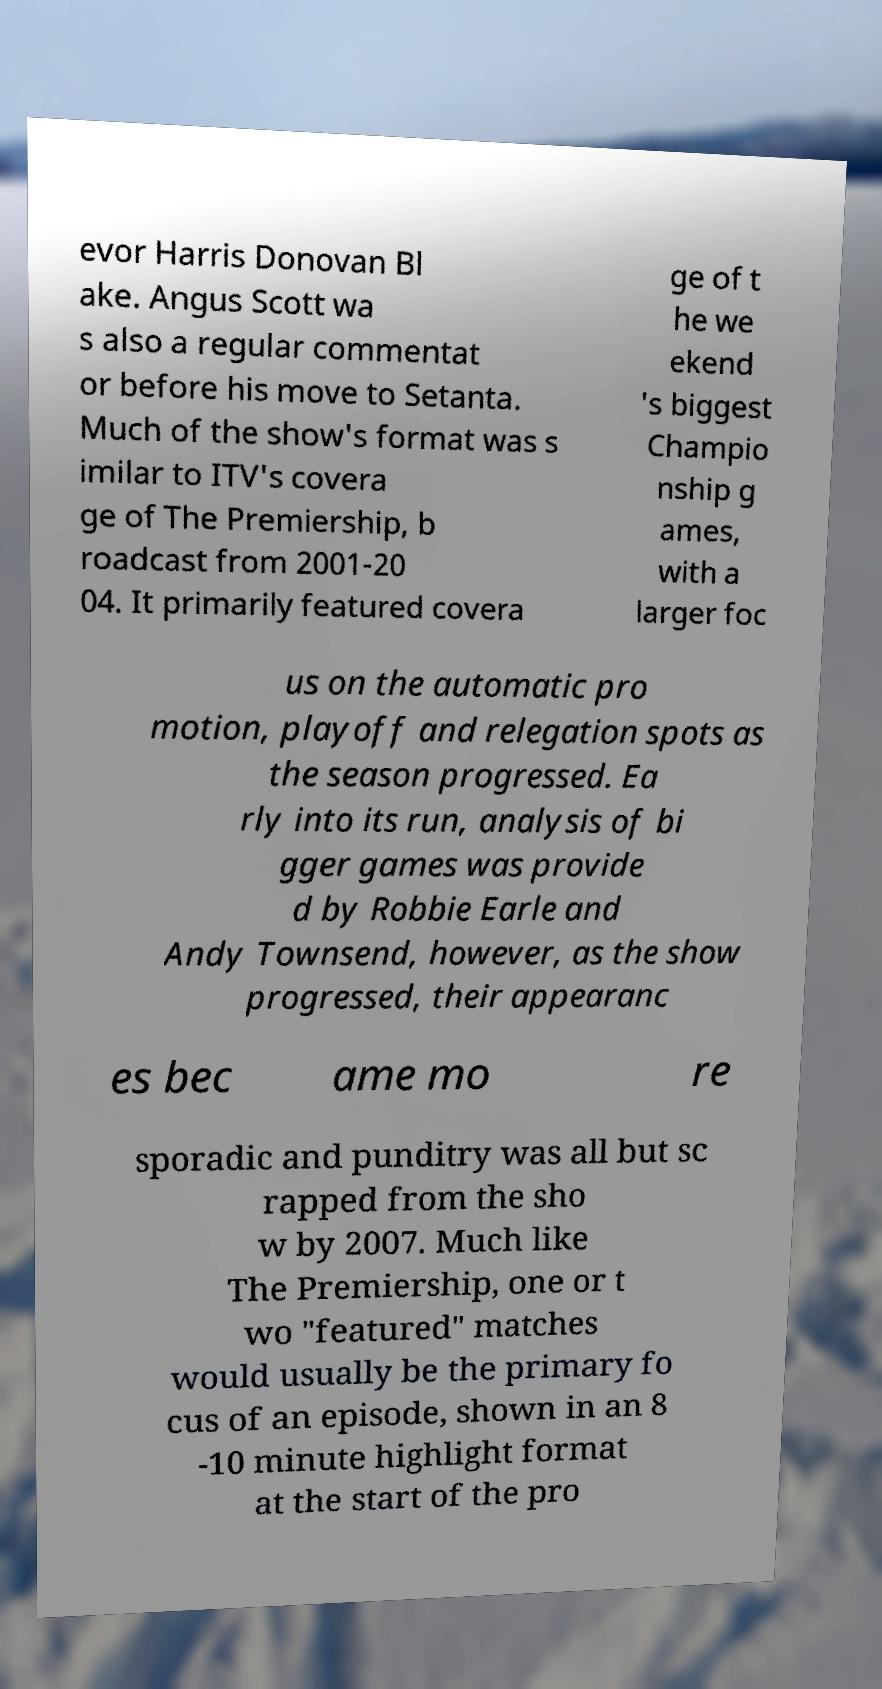Can you accurately transcribe the text from the provided image for me? evor Harris Donovan Bl ake. Angus Scott wa s also a regular commentat or before his move to Setanta. Much of the show's format was s imilar to ITV's covera ge of The Premiership, b roadcast from 2001-20 04. It primarily featured covera ge of t he we ekend 's biggest Champio nship g ames, with a larger foc us on the automatic pro motion, playoff and relegation spots as the season progressed. Ea rly into its run, analysis of bi gger games was provide d by Robbie Earle and Andy Townsend, however, as the show progressed, their appearanc es bec ame mo re sporadic and punditry was all but sc rapped from the sho w by 2007. Much like The Premiership, one or t wo "featured" matches would usually be the primary fo cus of an episode, shown in an 8 -10 minute highlight format at the start of the pro 